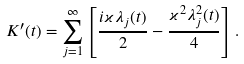Convert formula to latex. <formula><loc_0><loc_0><loc_500><loc_500>K ^ { \prime } ( t ) = \sum _ { j = 1 } ^ { \infty } \left [ \frac { i \varkappa \lambda _ { j } ( t ) } { 2 } - \frac { \varkappa ^ { 2 } \lambda ^ { 2 } _ { j } ( t ) } { 4 } \right ] .</formula> 